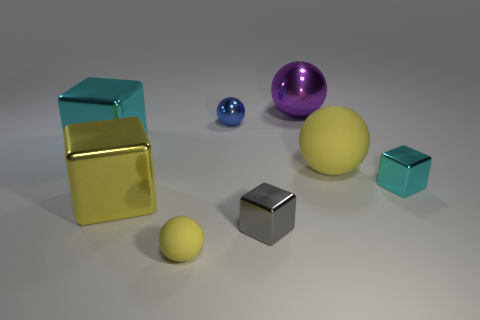What number of other objects are there of the same material as the gray block?
Offer a terse response. 5. There is a object that is right of the small yellow sphere and in front of the large yellow block; how big is it?
Provide a short and direct response. Small. There is a big metallic object right of the metal sphere that is in front of the purple thing; what is its shape?
Offer a very short reply. Sphere. Is there any other thing that is the same shape as the purple shiny thing?
Provide a short and direct response. Yes. Is the number of small yellow rubber things in front of the tiny cyan block the same as the number of big red shiny spheres?
Keep it short and to the point. No. There is a tiny rubber sphere; is its color the same as the large cube behind the yellow shiny cube?
Offer a terse response. No. What is the color of the metal object that is in front of the small cyan block and to the left of the small blue object?
Keep it short and to the point. Yellow. There is a yellow object to the right of the gray thing; how many purple objects are behind it?
Offer a very short reply. 1. Is there a purple thing that has the same shape as the large yellow rubber object?
Offer a very short reply. Yes. There is a large cyan shiny object to the left of the purple ball; does it have the same shape as the metal thing that is on the right side of the large yellow rubber ball?
Your response must be concise. Yes. 